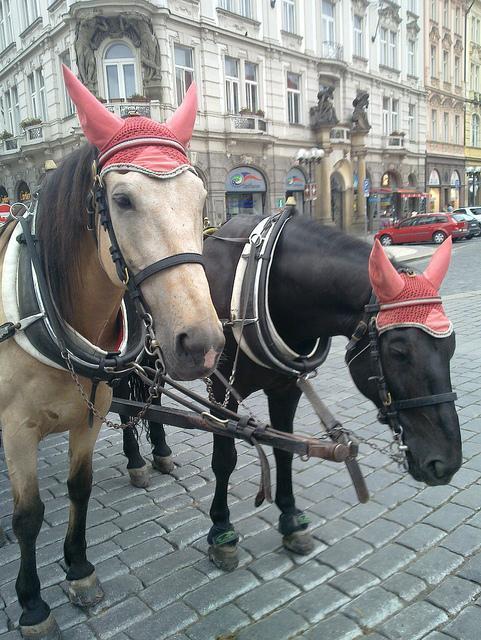How many horses are visible?
Give a very brief answer. 2. How many horses are in the picture?
Give a very brief answer. 2. 